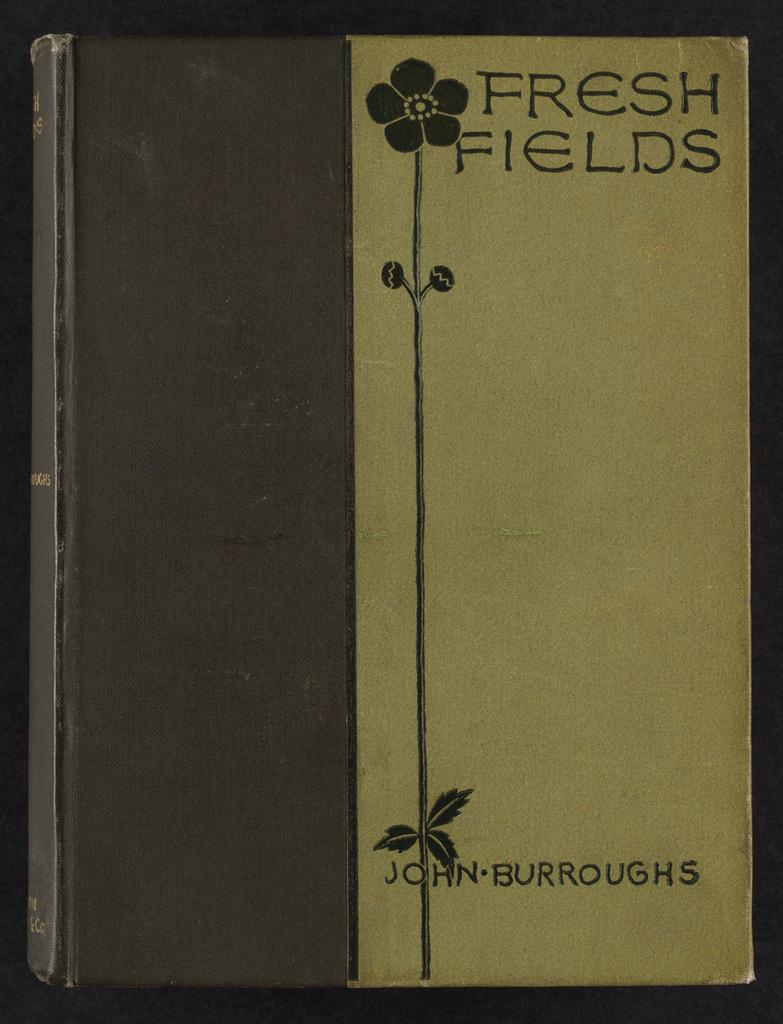Who wrote that book?
Give a very brief answer. John burroughs. What is this book called?
Your answer should be compact. Fresh fields. 